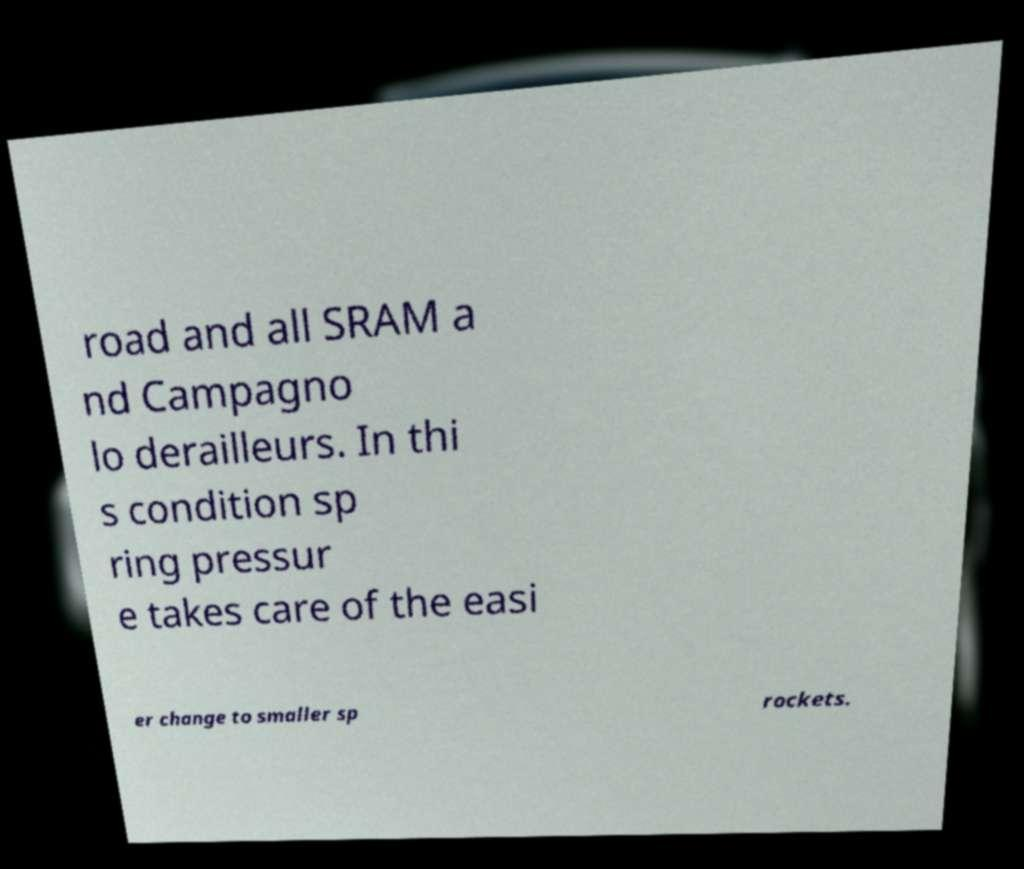Please read and relay the text visible in this image. What does it say? road and all SRAM a nd Campagno lo derailleurs. In thi s condition sp ring pressur e takes care of the easi er change to smaller sp rockets. 